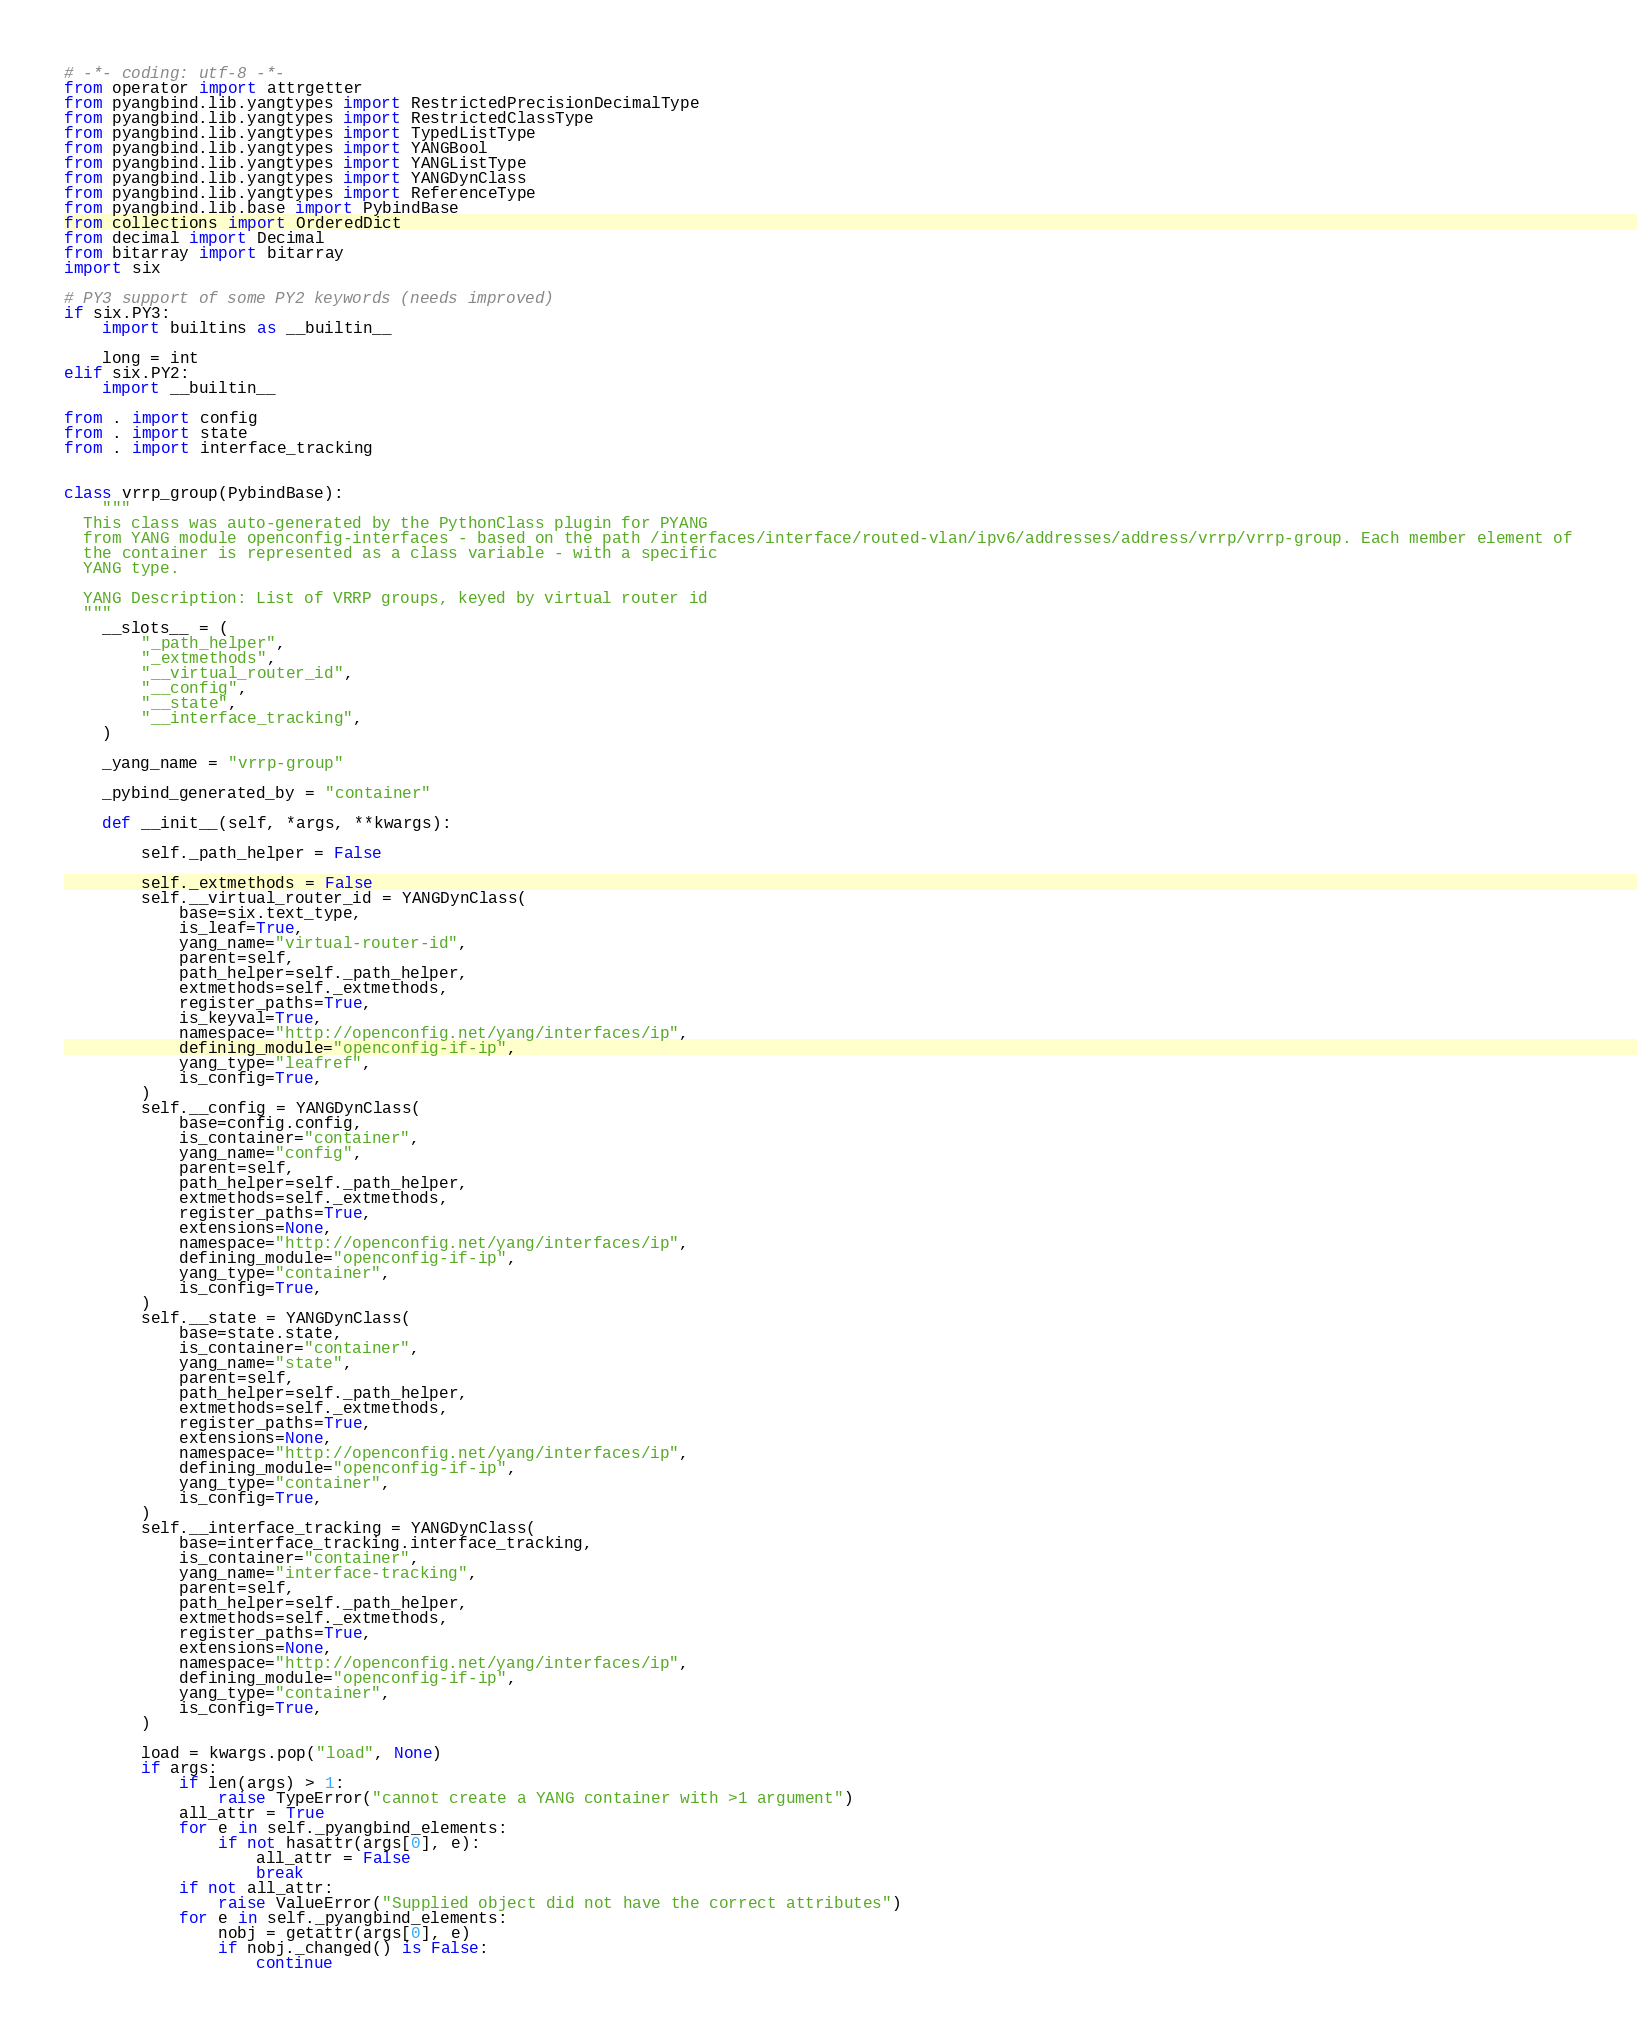<code> <loc_0><loc_0><loc_500><loc_500><_Python_># -*- coding: utf-8 -*-
from operator import attrgetter
from pyangbind.lib.yangtypes import RestrictedPrecisionDecimalType
from pyangbind.lib.yangtypes import RestrictedClassType
from pyangbind.lib.yangtypes import TypedListType
from pyangbind.lib.yangtypes import YANGBool
from pyangbind.lib.yangtypes import YANGListType
from pyangbind.lib.yangtypes import YANGDynClass
from pyangbind.lib.yangtypes import ReferenceType
from pyangbind.lib.base import PybindBase
from collections import OrderedDict
from decimal import Decimal
from bitarray import bitarray
import six

# PY3 support of some PY2 keywords (needs improved)
if six.PY3:
    import builtins as __builtin__

    long = int
elif six.PY2:
    import __builtin__

from . import config
from . import state
from . import interface_tracking


class vrrp_group(PybindBase):
    """
  This class was auto-generated by the PythonClass plugin for PYANG
  from YANG module openconfig-interfaces - based on the path /interfaces/interface/routed-vlan/ipv6/addresses/address/vrrp/vrrp-group. Each member element of
  the container is represented as a class variable - with a specific
  YANG type.

  YANG Description: List of VRRP groups, keyed by virtual router id
  """
    __slots__ = (
        "_path_helper",
        "_extmethods",
        "__virtual_router_id",
        "__config",
        "__state",
        "__interface_tracking",
    )

    _yang_name = "vrrp-group"

    _pybind_generated_by = "container"

    def __init__(self, *args, **kwargs):

        self._path_helper = False

        self._extmethods = False
        self.__virtual_router_id = YANGDynClass(
            base=six.text_type,
            is_leaf=True,
            yang_name="virtual-router-id",
            parent=self,
            path_helper=self._path_helper,
            extmethods=self._extmethods,
            register_paths=True,
            is_keyval=True,
            namespace="http://openconfig.net/yang/interfaces/ip",
            defining_module="openconfig-if-ip",
            yang_type="leafref",
            is_config=True,
        )
        self.__config = YANGDynClass(
            base=config.config,
            is_container="container",
            yang_name="config",
            parent=self,
            path_helper=self._path_helper,
            extmethods=self._extmethods,
            register_paths=True,
            extensions=None,
            namespace="http://openconfig.net/yang/interfaces/ip",
            defining_module="openconfig-if-ip",
            yang_type="container",
            is_config=True,
        )
        self.__state = YANGDynClass(
            base=state.state,
            is_container="container",
            yang_name="state",
            parent=self,
            path_helper=self._path_helper,
            extmethods=self._extmethods,
            register_paths=True,
            extensions=None,
            namespace="http://openconfig.net/yang/interfaces/ip",
            defining_module="openconfig-if-ip",
            yang_type="container",
            is_config=True,
        )
        self.__interface_tracking = YANGDynClass(
            base=interface_tracking.interface_tracking,
            is_container="container",
            yang_name="interface-tracking",
            parent=self,
            path_helper=self._path_helper,
            extmethods=self._extmethods,
            register_paths=True,
            extensions=None,
            namespace="http://openconfig.net/yang/interfaces/ip",
            defining_module="openconfig-if-ip",
            yang_type="container",
            is_config=True,
        )

        load = kwargs.pop("load", None)
        if args:
            if len(args) > 1:
                raise TypeError("cannot create a YANG container with >1 argument")
            all_attr = True
            for e in self._pyangbind_elements:
                if not hasattr(args[0], e):
                    all_attr = False
                    break
            if not all_attr:
                raise ValueError("Supplied object did not have the correct attributes")
            for e in self._pyangbind_elements:
                nobj = getattr(args[0], e)
                if nobj._changed() is False:
                    continue</code> 